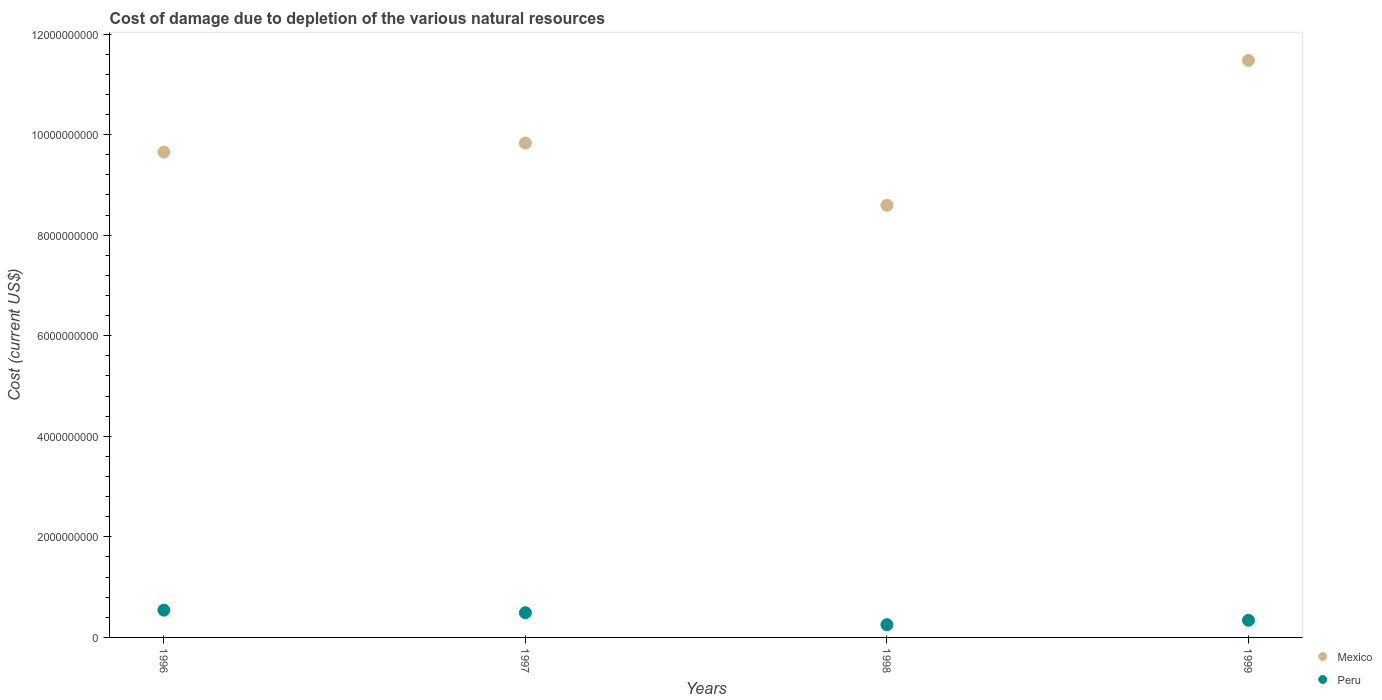How many different coloured dotlines are there?
Ensure brevity in your answer.  2. What is the cost of damage caused due to the depletion of various natural resources in Mexico in 1997?
Offer a terse response. 9.83e+09. Across all years, what is the maximum cost of damage caused due to the depletion of various natural resources in Peru?
Your answer should be compact. 5.42e+08. Across all years, what is the minimum cost of damage caused due to the depletion of various natural resources in Mexico?
Provide a short and direct response. 8.60e+09. In which year was the cost of damage caused due to the depletion of various natural resources in Peru minimum?
Provide a succinct answer. 1998. What is the total cost of damage caused due to the depletion of various natural resources in Mexico in the graph?
Provide a short and direct response. 3.96e+1. What is the difference between the cost of damage caused due to the depletion of various natural resources in Mexico in 1997 and that in 1998?
Your answer should be compact. 1.24e+09. What is the difference between the cost of damage caused due to the depletion of various natural resources in Mexico in 1997 and the cost of damage caused due to the depletion of various natural resources in Peru in 1999?
Give a very brief answer. 9.49e+09. What is the average cost of damage caused due to the depletion of various natural resources in Peru per year?
Provide a succinct answer. 4.07e+08. In the year 1996, what is the difference between the cost of damage caused due to the depletion of various natural resources in Mexico and cost of damage caused due to the depletion of various natural resources in Peru?
Provide a short and direct response. 9.11e+09. In how many years, is the cost of damage caused due to the depletion of various natural resources in Peru greater than 11200000000 US$?
Ensure brevity in your answer.  0. What is the ratio of the cost of damage caused due to the depletion of various natural resources in Peru in 1998 to that in 1999?
Provide a short and direct response. 0.74. Is the cost of damage caused due to the depletion of various natural resources in Mexico in 1997 less than that in 1999?
Give a very brief answer. Yes. Is the difference between the cost of damage caused due to the depletion of various natural resources in Mexico in 1997 and 1999 greater than the difference between the cost of damage caused due to the depletion of various natural resources in Peru in 1997 and 1999?
Make the answer very short. No. What is the difference between the highest and the second highest cost of damage caused due to the depletion of various natural resources in Peru?
Your answer should be compact. 5.15e+07. What is the difference between the highest and the lowest cost of damage caused due to the depletion of various natural resources in Peru?
Your answer should be very brief. 2.89e+08. Is the sum of the cost of damage caused due to the depletion of various natural resources in Mexico in 1996 and 1999 greater than the maximum cost of damage caused due to the depletion of various natural resources in Peru across all years?
Offer a terse response. Yes. Is the cost of damage caused due to the depletion of various natural resources in Mexico strictly greater than the cost of damage caused due to the depletion of various natural resources in Peru over the years?
Offer a very short reply. Yes. Is the cost of damage caused due to the depletion of various natural resources in Mexico strictly less than the cost of damage caused due to the depletion of various natural resources in Peru over the years?
Your answer should be very brief. No. Are the values on the major ticks of Y-axis written in scientific E-notation?
Your answer should be very brief. No. Does the graph contain grids?
Keep it short and to the point. No. How many legend labels are there?
Ensure brevity in your answer.  2. What is the title of the graph?
Give a very brief answer. Cost of damage due to depletion of the various natural resources. What is the label or title of the X-axis?
Your answer should be compact. Years. What is the label or title of the Y-axis?
Provide a succinct answer. Cost (current US$). What is the Cost (current US$) in Mexico in 1996?
Your answer should be compact. 9.65e+09. What is the Cost (current US$) in Peru in 1996?
Make the answer very short. 5.42e+08. What is the Cost (current US$) of Mexico in 1997?
Provide a short and direct response. 9.83e+09. What is the Cost (current US$) in Peru in 1997?
Your answer should be very brief. 4.91e+08. What is the Cost (current US$) of Mexico in 1998?
Provide a succinct answer. 8.60e+09. What is the Cost (current US$) of Peru in 1998?
Ensure brevity in your answer.  2.54e+08. What is the Cost (current US$) in Mexico in 1999?
Provide a succinct answer. 1.15e+1. What is the Cost (current US$) of Peru in 1999?
Provide a short and direct response. 3.41e+08. Across all years, what is the maximum Cost (current US$) in Mexico?
Your response must be concise. 1.15e+1. Across all years, what is the maximum Cost (current US$) of Peru?
Provide a succinct answer. 5.42e+08. Across all years, what is the minimum Cost (current US$) of Mexico?
Your answer should be compact. 8.60e+09. Across all years, what is the minimum Cost (current US$) in Peru?
Ensure brevity in your answer.  2.54e+08. What is the total Cost (current US$) of Mexico in the graph?
Ensure brevity in your answer.  3.96e+1. What is the total Cost (current US$) in Peru in the graph?
Your response must be concise. 1.63e+09. What is the difference between the Cost (current US$) in Mexico in 1996 and that in 1997?
Your response must be concise. -1.79e+08. What is the difference between the Cost (current US$) of Peru in 1996 and that in 1997?
Your answer should be very brief. 5.15e+07. What is the difference between the Cost (current US$) of Mexico in 1996 and that in 1998?
Make the answer very short. 1.06e+09. What is the difference between the Cost (current US$) in Peru in 1996 and that in 1998?
Keep it short and to the point. 2.89e+08. What is the difference between the Cost (current US$) in Mexico in 1996 and that in 1999?
Your response must be concise. -1.82e+09. What is the difference between the Cost (current US$) of Peru in 1996 and that in 1999?
Ensure brevity in your answer.  2.01e+08. What is the difference between the Cost (current US$) of Mexico in 1997 and that in 1998?
Provide a short and direct response. 1.24e+09. What is the difference between the Cost (current US$) of Peru in 1997 and that in 1998?
Your response must be concise. 2.37e+08. What is the difference between the Cost (current US$) in Mexico in 1997 and that in 1999?
Your answer should be very brief. -1.64e+09. What is the difference between the Cost (current US$) of Peru in 1997 and that in 1999?
Keep it short and to the point. 1.50e+08. What is the difference between the Cost (current US$) of Mexico in 1998 and that in 1999?
Offer a terse response. -2.88e+09. What is the difference between the Cost (current US$) in Peru in 1998 and that in 1999?
Offer a terse response. -8.76e+07. What is the difference between the Cost (current US$) in Mexico in 1996 and the Cost (current US$) in Peru in 1997?
Make the answer very short. 9.16e+09. What is the difference between the Cost (current US$) of Mexico in 1996 and the Cost (current US$) of Peru in 1998?
Provide a succinct answer. 9.40e+09. What is the difference between the Cost (current US$) of Mexico in 1996 and the Cost (current US$) of Peru in 1999?
Offer a terse response. 9.31e+09. What is the difference between the Cost (current US$) in Mexico in 1997 and the Cost (current US$) in Peru in 1998?
Provide a succinct answer. 9.58e+09. What is the difference between the Cost (current US$) in Mexico in 1997 and the Cost (current US$) in Peru in 1999?
Make the answer very short. 9.49e+09. What is the difference between the Cost (current US$) in Mexico in 1998 and the Cost (current US$) in Peru in 1999?
Offer a terse response. 8.25e+09. What is the average Cost (current US$) of Mexico per year?
Your answer should be very brief. 9.89e+09. What is the average Cost (current US$) in Peru per year?
Your answer should be very brief. 4.07e+08. In the year 1996, what is the difference between the Cost (current US$) of Mexico and Cost (current US$) of Peru?
Your answer should be very brief. 9.11e+09. In the year 1997, what is the difference between the Cost (current US$) of Mexico and Cost (current US$) of Peru?
Provide a short and direct response. 9.34e+09. In the year 1998, what is the difference between the Cost (current US$) of Mexico and Cost (current US$) of Peru?
Give a very brief answer. 8.34e+09. In the year 1999, what is the difference between the Cost (current US$) of Mexico and Cost (current US$) of Peru?
Keep it short and to the point. 1.11e+1. What is the ratio of the Cost (current US$) in Mexico in 1996 to that in 1997?
Make the answer very short. 0.98. What is the ratio of the Cost (current US$) of Peru in 1996 to that in 1997?
Provide a succinct answer. 1.1. What is the ratio of the Cost (current US$) in Mexico in 1996 to that in 1998?
Ensure brevity in your answer.  1.12. What is the ratio of the Cost (current US$) in Peru in 1996 to that in 1998?
Your answer should be very brief. 2.14. What is the ratio of the Cost (current US$) of Mexico in 1996 to that in 1999?
Offer a very short reply. 0.84. What is the ratio of the Cost (current US$) of Peru in 1996 to that in 1999?
Your answer should be compact. 1.59. What is the ratio of the Cost (current US$) in Mexico in 1997 to that in 1998?
Your answer should be compact. 1.14. What is the ratio of the Cost (current US$) in Peru in 1997 to that in 1998?
Provide a short and direct response. 1.93. What is the ratio of the Cost (current US$) in Mexico in 1997 to that in 1999?
Your answer should be compact. 0.86. What is the ratio of the Cost (current US$) of Peru in 1997 to that in 1999?
Provide a succinct answer. 1.44. What is the ratio of the Cost (current US$) in Mexico in 1998 to that in 1999?
Your response must be concise. 0.75. What is the ratio of the Cost (current US$) of Peru in 1998 to that in 1999?
Provide a succinct answer. 0.74. What is the difference between the highest and the second highest Cost (current US$) of Mexico?
Your answer should be compact. 1.64e+09. What is the difference between the highest and the second highest Cost (current US$) in Peru?
Ensure brevity in your answer.  5.15e+07. What is the difference between the highest and the lowest Cost (current US$) in Mexico?
Keep it short and to the point. 2.88e+09. What is the difference between the highest and the lowest Cost (current US$) in Peru?
Give a very brief answer. 2.89e+08. 